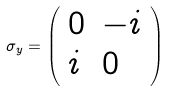Convert formula to latex. <formula><loc_0><loc_0><loc_500><loc_500>\sigma _ { y } = { \left ( \begin{array} { l l } { 0 } & { - i } \\ { i } & { 0 } \end{array} \right ) }</formula> 